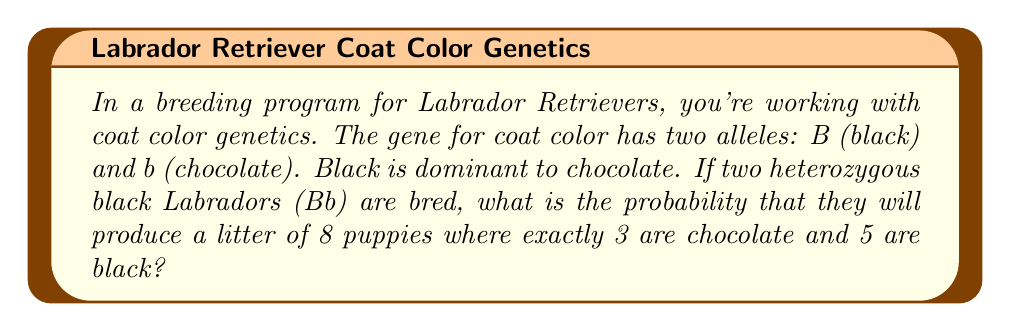Can you answer this question? Let's approach this step-by-step:

1) First, we need to determine the probability of a puppy being chocolate or black from two heterozygous (Bb) parents:

   - Possible genotypes: BB, Bb, bB, bb
   - Probability of each: 1/4, 1/4, 1/4, 1/4
   - Phenotype probabilities: 
     Black (BB, Bb, bB): 3/4
     Chocolate (bb): 1/4

2) Now, we can model this as a binomial probability problem. We want exactly 3 chocolate puppies out of 8.

3) The probability mass function for a binomial distribution is:

   $$ P(X = k) = \binom{n}{k} p^k (1-p)^{n-k} $$

   Where:
   $n$ = total number of puppies = 8
   $k$ = number of chocolate puppies = 3
   $p$ = probability of a puppy being chocolate = 1/4

4) Plugging in our values:

   $$ P(X = 3) = \binom{8}{3} (1/4)^3 (3/4)^{8-3} $$

5) Calculating:

   $$ P(X = 3) = 56 * (1/64) * (243/1024) $$

6) Simplifying:

   $$ P(X = 3) = \frac{56 * 243}{64 * 1024} = \frac{13608}{65536} \approx 0.2076 $$

Therefore, the probability of having exactly 3 chocolate puppies and 5 black puppies in a litter of 8 is approximately 0.2076 or 20.76%.
Answer: $\frac{13608}{65536}$ or approximately 0.2076 